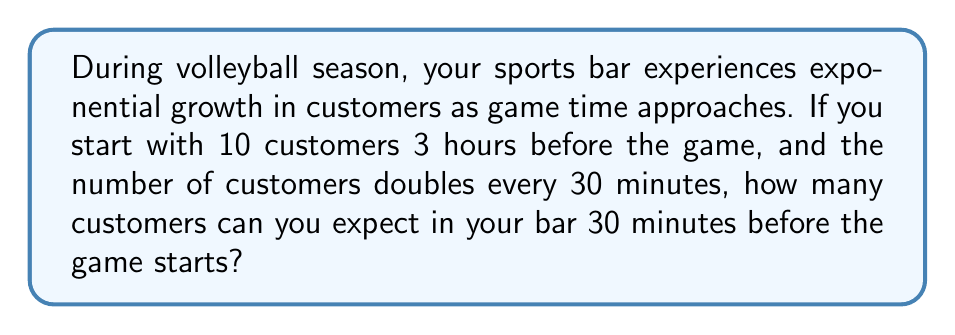Help me with this question. Let's approach this step-by-step:

1) We start with 10 customers 3 hours before the game.

2) The number of customers doubles every 30 minutes.

3) From 3 hours before the game to 30 minutes before the game, there are 5 doubling periods:
   3 hours → 2.5 hours → 2 hours → 1.5 hours → 1 hour → 30 minutes

4) We can represent this with an exponential sequence:
   $a_n = 10 \cdot 2^n$, where $n$ is the number of 30-minute periods that have passed.

5) We want to find $a_5$, as there are 5 doubling periods.

6) $a_5 = 10 \cdot 2^5$

7) Let's calculate:
   $$\begin{align}
   a_5 &= 10 \cdot 2^5 \\
   &= 10 \cdot 32 \\
   &= 320
   \end{align}$$

Therefore, 30 minutes before the game starts, you can expect 320 customers in your bar.
Answer: 320 customers 